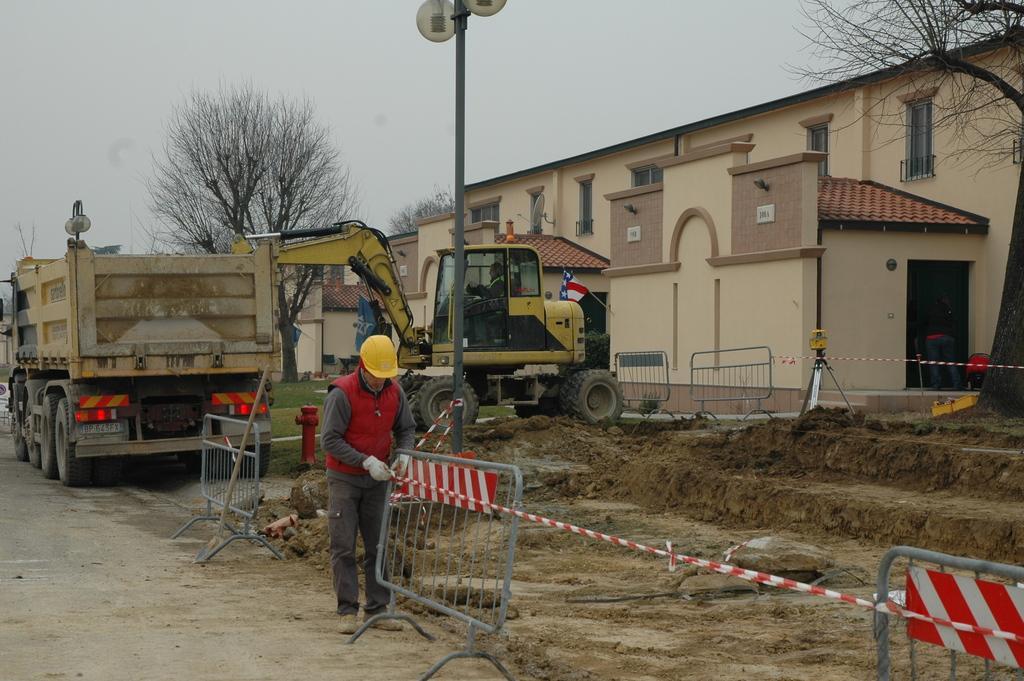Describe this image in one or two sentences. In this picture we can see barricades, a person, a truck, a proclainer and an object on the ground. On the right side of the proclainer, there are street lights, buildings, trees and the sky. 